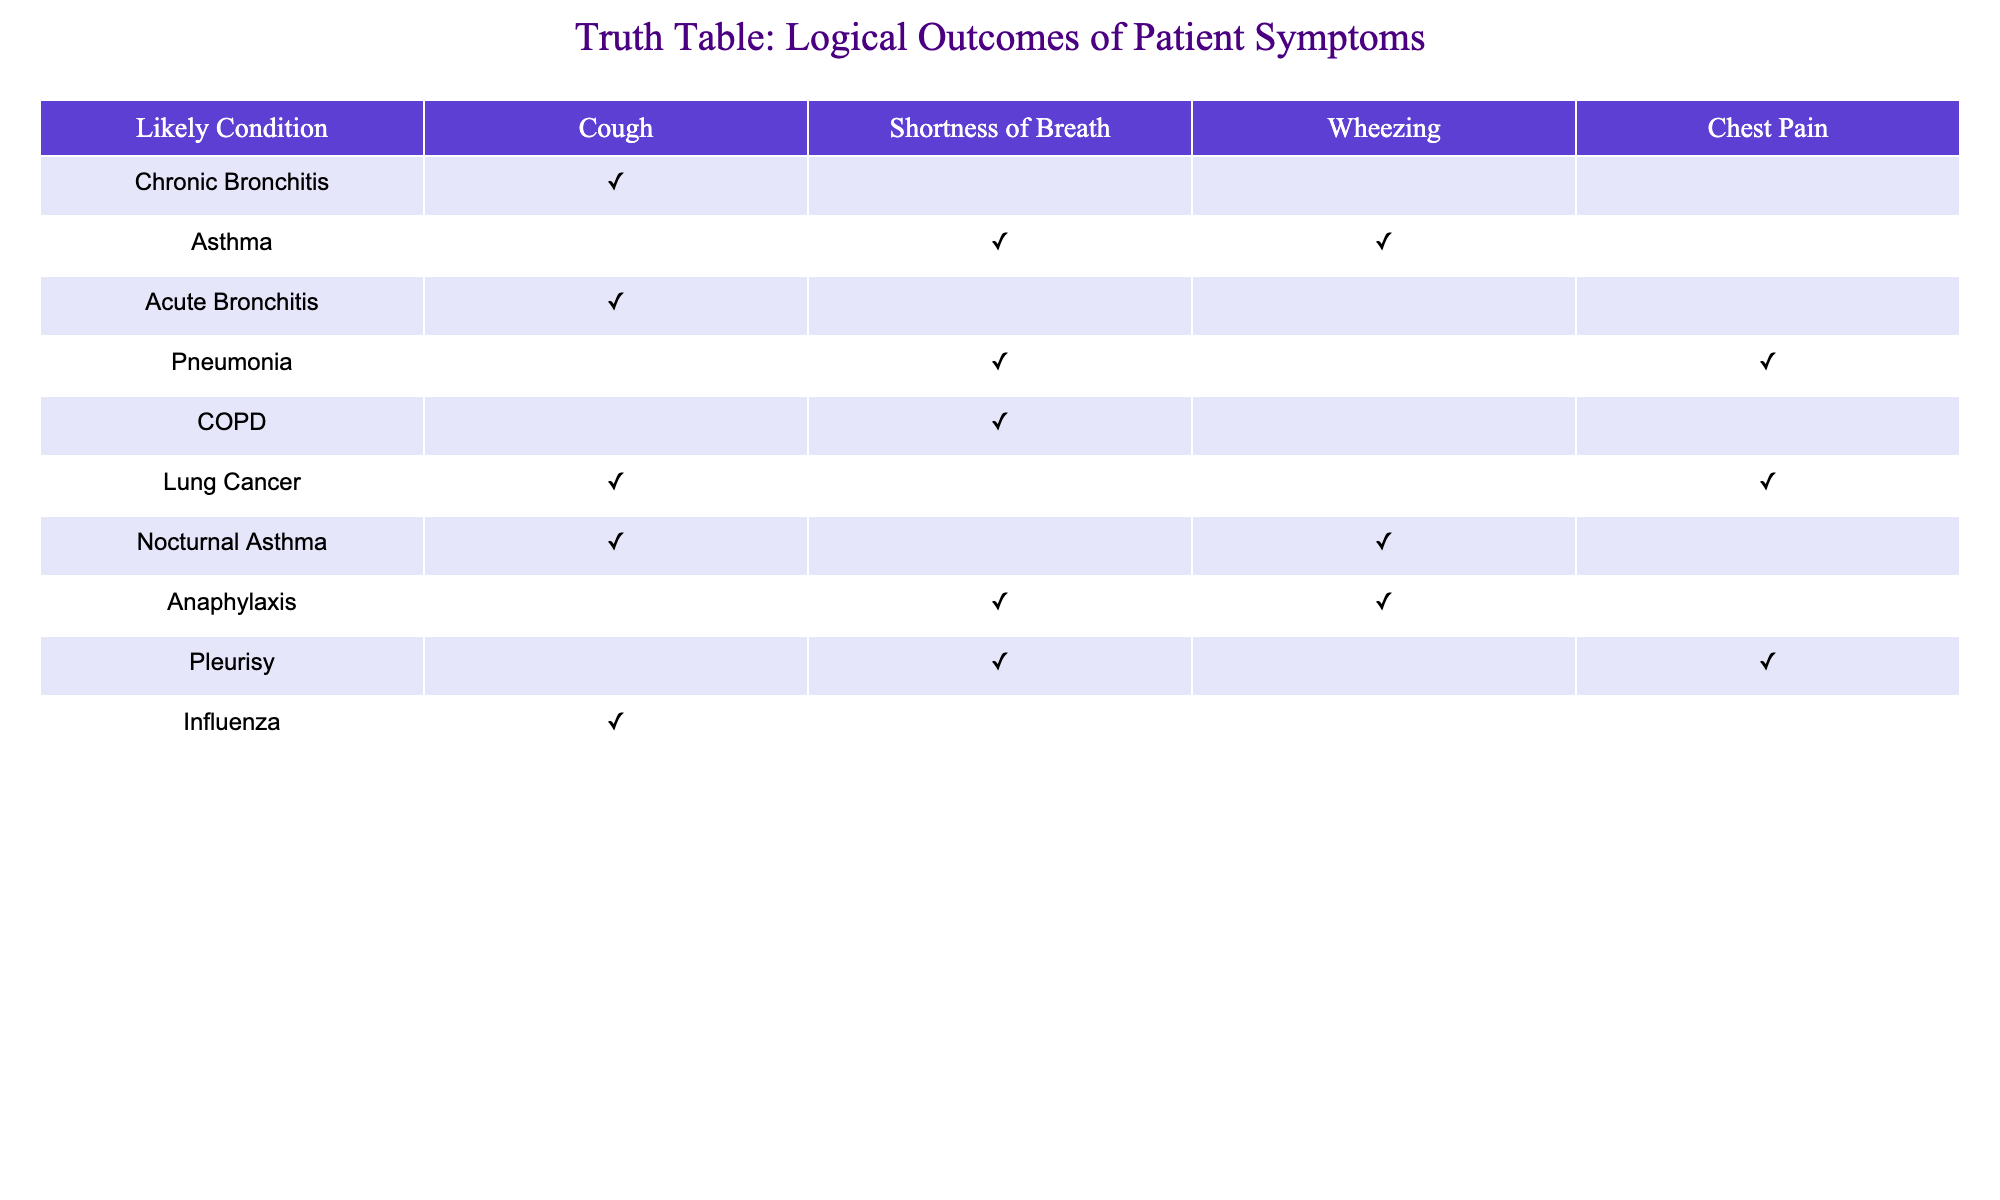What condition is associated with a dry persistent cough? According to the table, the condition linked with a dry persistent cough is Chronic Bronchitis, as it is the only entry that corresponds with this symptom.
Answer: Chronic Bronchitis How many conditions show wheezing as a symptom? By examining the table, there are three conditions that feature wheezing: Asthma, Nocturnal Asthma, and Anaphylaxis. Thus, the total count is three.
Answer: 3 Does chest pain worsen when breathing indicate pneumonia? Looking at the table, the entry for pneumonia includes severe chest pain associated with shortness of breath but does not specify worsening with breathing. Thus, the condition is not confirmed by this symptom alone.
Answer: No Is cough with blood present in Lung Cancer? The table shows that the symptom of cough with blood corresponds to Lung Cancer, indicating that this symptom is indeed associated with the condition.
Answer: Yes What conditions are indicated if a patient exhibits shortness of breath with exertion? The table shows that shortness of breath with exertion is associated with COPD. Therefore, this condition is indicated when observing this symptom.
Answer: COPD How many symptoms are linked to Pneumonia? In the table for pneumonia, there are two listed symptoms: shortness of breath and chest pain. This means there are two symptoms connected to this condition.
Answer: 2 Are there any conditions identified that include cough and chest pain together? Upon reviewing the table, both cough with blood and severe chest pain have overlap in respect to chest pain; however, none of the conditions show both symptoms together distinctly. Therefore, the answer is negative.
Answer: No What is the likely condition for a patient with wheezing and chest tightness? The data indicates that a patient exhibiting both wheezing and chest tightness is likely suffering from Asthma, as this condition specifically points to both symptoms in the table.
Answer: Asthma If a patient presents with cough and fever, which condition should they be checked for? The table indicates that cough and fever are symptoms linked to Influenza. Therefore, checking for Influenza should be advised for a patient with these symptoms.
Answer: Influenza 